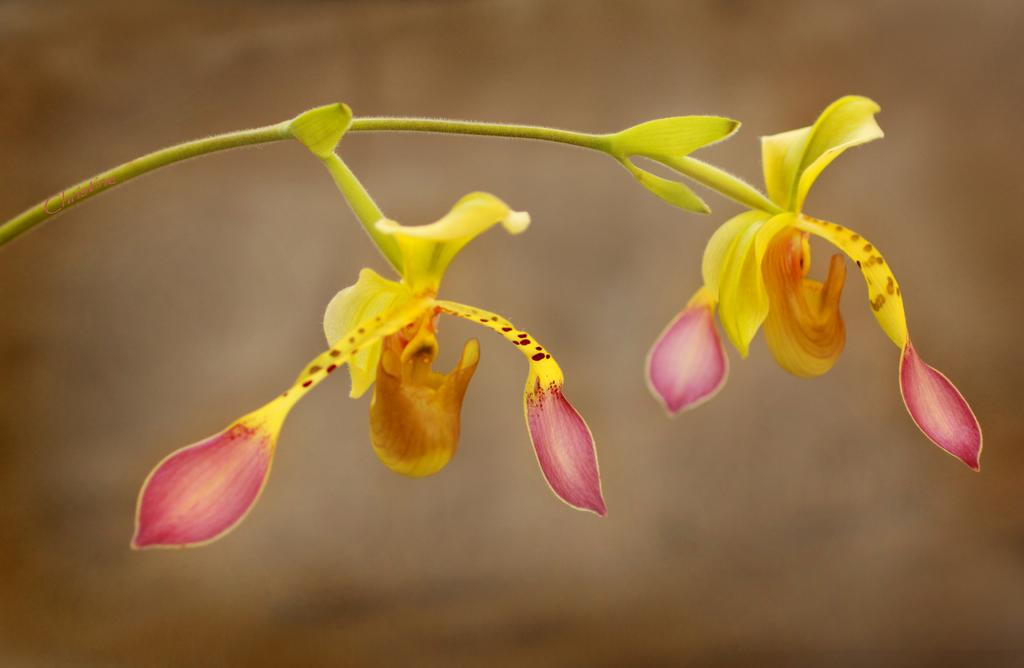What type of plant can be seen in the image? There is a flowering plant in the image. What color is visible in the image? The color brown is present in the image. Where might this image have been taken? The image may have been taken in a garden. What type of education can be seen in the image? There is no reference to education in the image; it features a flowering plant and the color brown. How does the toothpaste roll in the image? There is no toothpaste present in the image. 